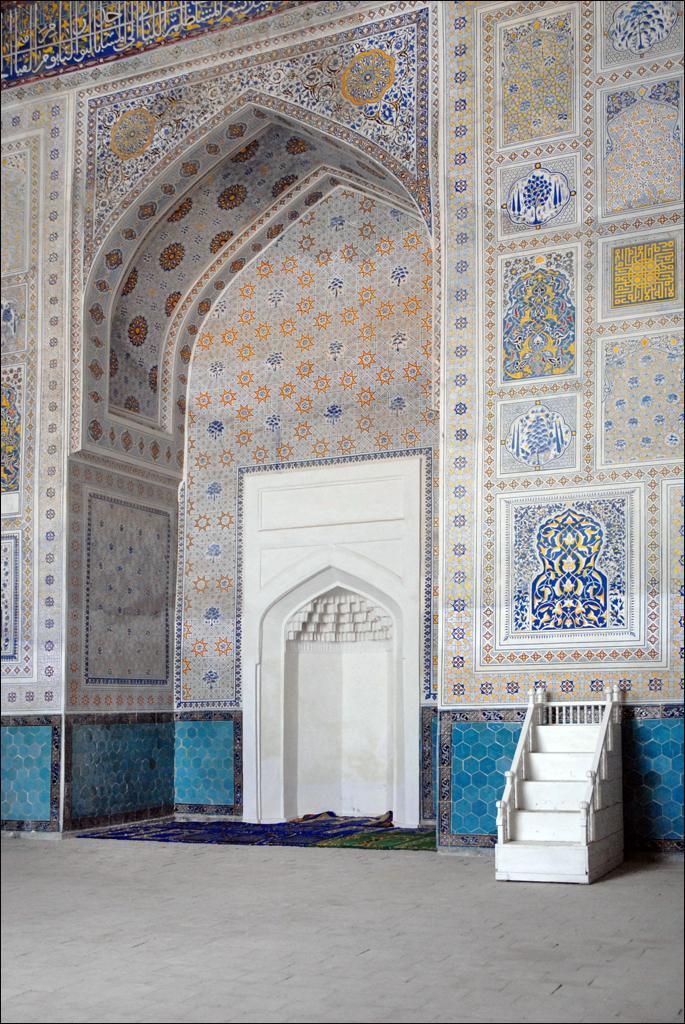Could you give a brief overview of what you see in this image? In this picture we can see an arch here, on the right side there are stars, we can see wall designs here. 